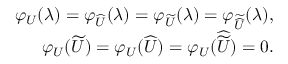<formula> <loc_0><loc_0><loc_500><loc_500>\begin{array} { r l r } & { \varphi _ { U } ( \lambda ) = \varphi _ { \widehat { U } } ( \lambda ) = \varphi _ { \widetilde { U } } ( \lambda ) = \varphi _ { \widetilde { \widehat { U } } } ( \lambda ) , } \\ & { \varphi _ { U } ( \widetilde { U } ) = \varphi _ { U } ( \widehat { U } ) = \varphi _ { U } ( \widehat { \widetilde { U } } ) = 0 . } \end{array}</formula> 